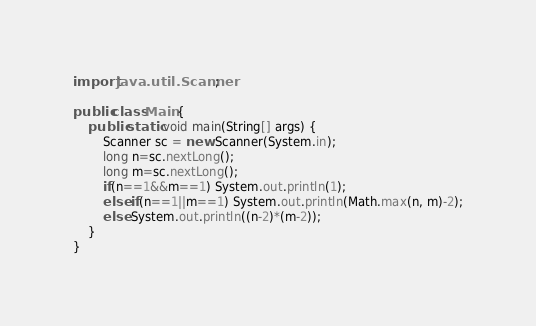<code> <loc_0><loc_0><loc_500><loc_500><_Java_>import java.util.Scanner;

public class Main {
	public static void main(String[] args) {
		Scanner sc = new Scanner(System.in);
		long n=sc.nextLong();
		long m=sc.nextLong();
		if(n==1&&m==1) System.out.println(1);
		else if(n==1||m==1) System.out.println(Math.max(n, m)-2);
		else System.out.println((n-2)*(m-2));
	}
}
</code> 